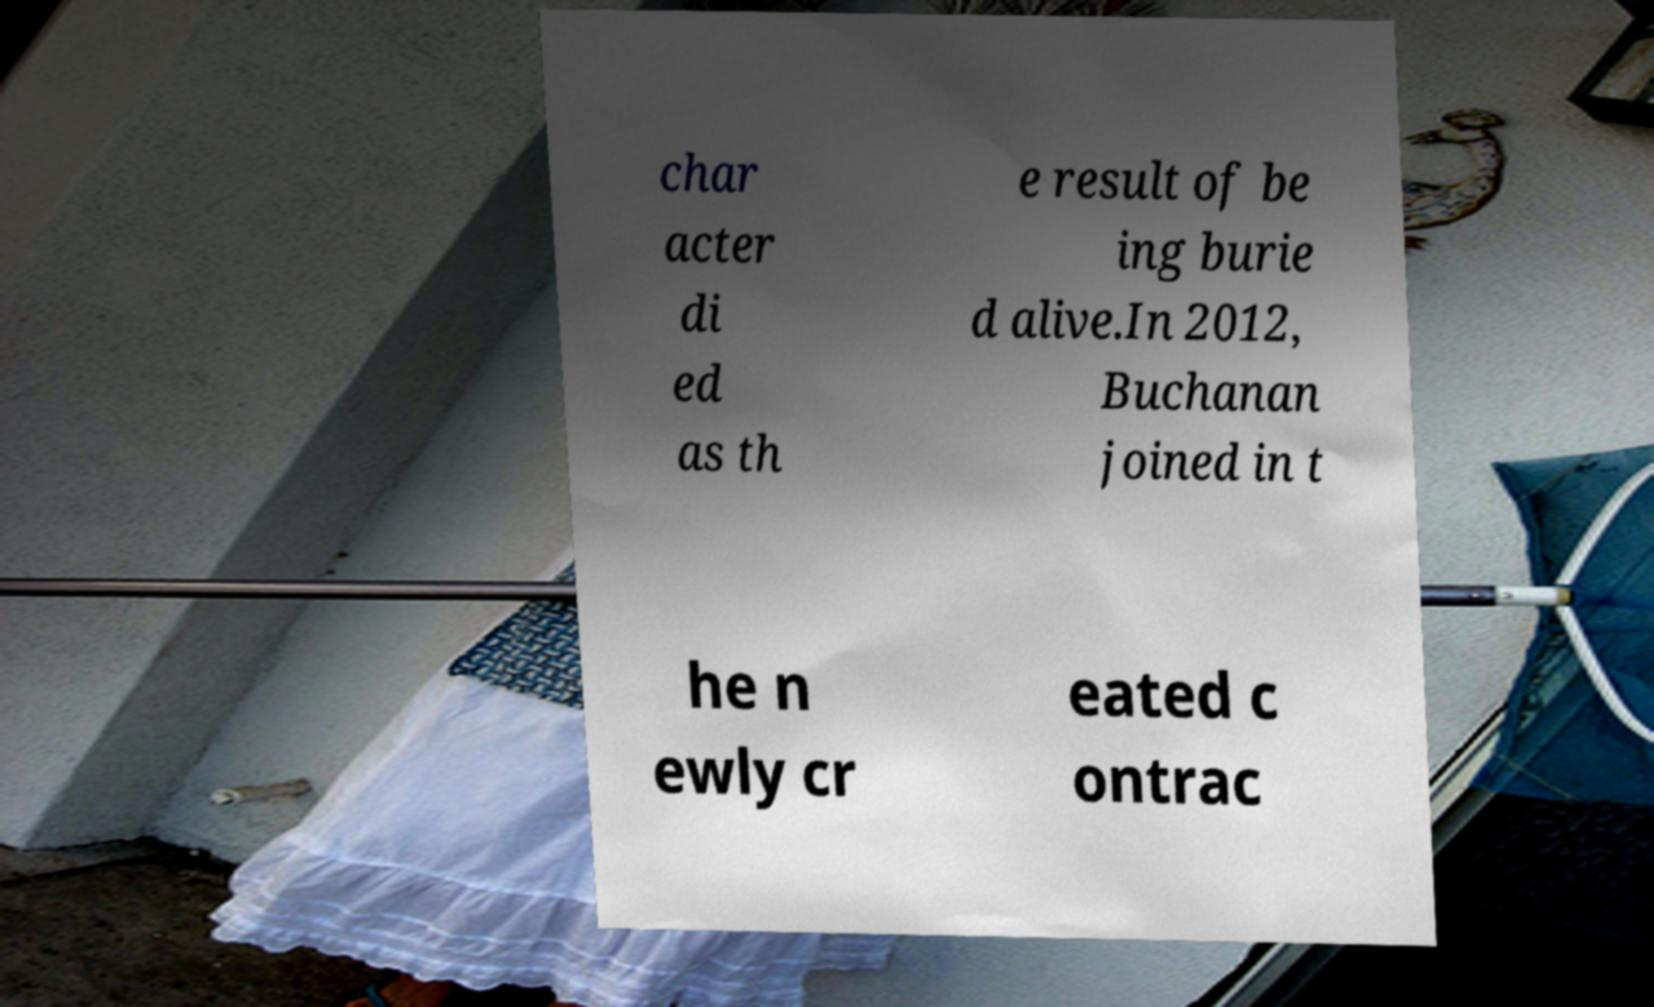What messages or text are displayed in this image? I need them in a readable, typed format. char acter di ed as th e result of be ing burie d alive.In 2012, Buchanan joined in t he n ewly cr eated c ontrac 